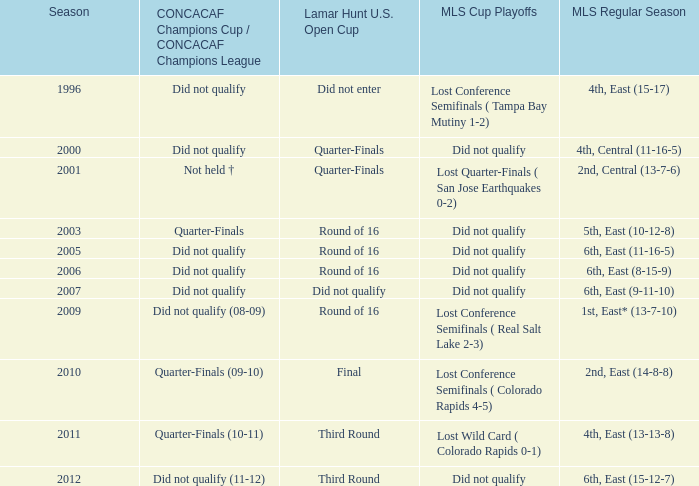Could you help me parse every detail presented in this table? {'header': ['Season', 'CONCACAF Champions Cup / CONCACAF Champions League', 'Lamar Hunt U.S. Open Cup', 'MLS Cup Playoffs', 'MLS Regular Season'], 'rows': [['1996', 'Did not qualify', 'Did not enter', 'Lost Conference Semifinals ( Tampa Bay Mutiny 1-2)', '4th, East (15-17)'], ['2000', 'Did not qualify', 'Quarter-Finals', 'Did not qualify', '4th, Central (11-16-5)'], ['2001', 'Not held †', 'Quarter-Finals', 'Lost Quarter-Finals ( San Jose Earthquakes 0-2)', '2nd, Central (13-7-6)'], ['2003', 'Quarter-Finals', 'Round of 16', 'Did not qualify', '5th, East (10-12-8)'], ['2005', 'Did not qualify', 'Round of 16', 'Did not qualify', '6th, East (11-16-5)'], ['2006', 'Did not qualify', 'Round of 16', 'Did not qualify', '6th, East (8-15-9)'], ['2007', 'Did not qualify', 'Did not qualify', 'Did not qualify', '6th, East (9-11-10)'], ['2009', 'Did not qualify (08-09)', 'Round of 16', 'Lost Conference Semifinals ( Real Salt Lake 2-3)', '1st, East* (13-7-10)'], ['2010', 'Quarter-Finals (09-10)', 'Final', 'Lost Conference Semifinals ( Colorado Rapids 4-5)', '2nd, East (14-8-8)'], ['2011', 'Quarter-Finals (10-11)', 'Third Round', 'Lost Wild Card ( Colorado Rapids 0-1)', '4th, East (13-13-8)'], ['2012', 'Did not qualify (11-12)', 'Third Round', 'Did not qualify', '6th, East (15-12-7)']]} What was the season when mls regular season was 6th, east (9-11-10)? 2007.0. 